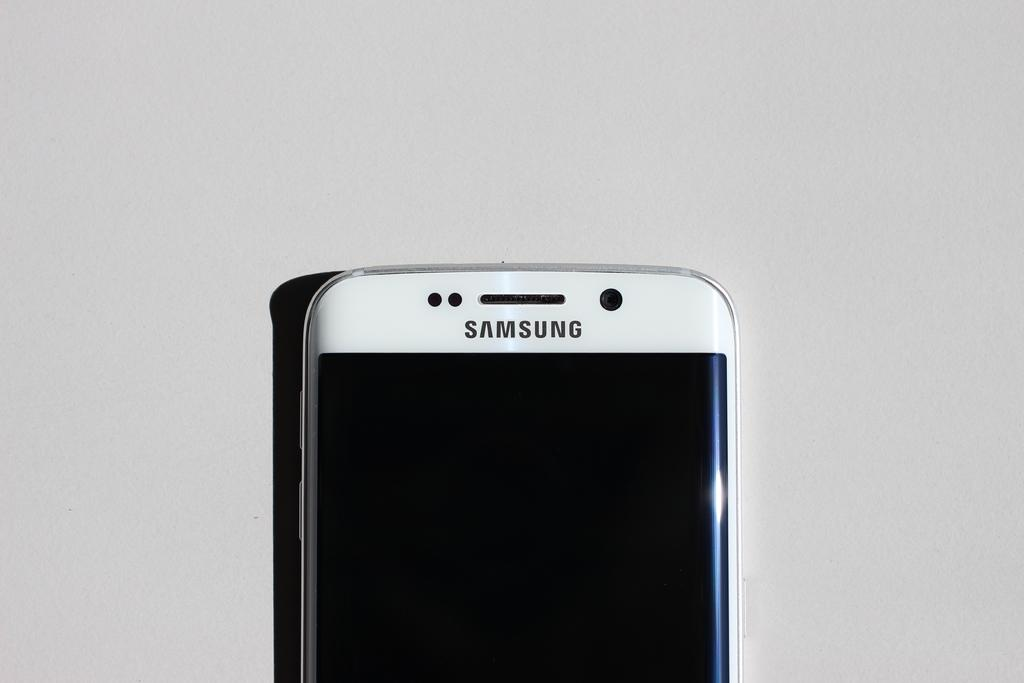<image>
Provide a brief description of the given image. A white Samsung phone against a white back drop. 